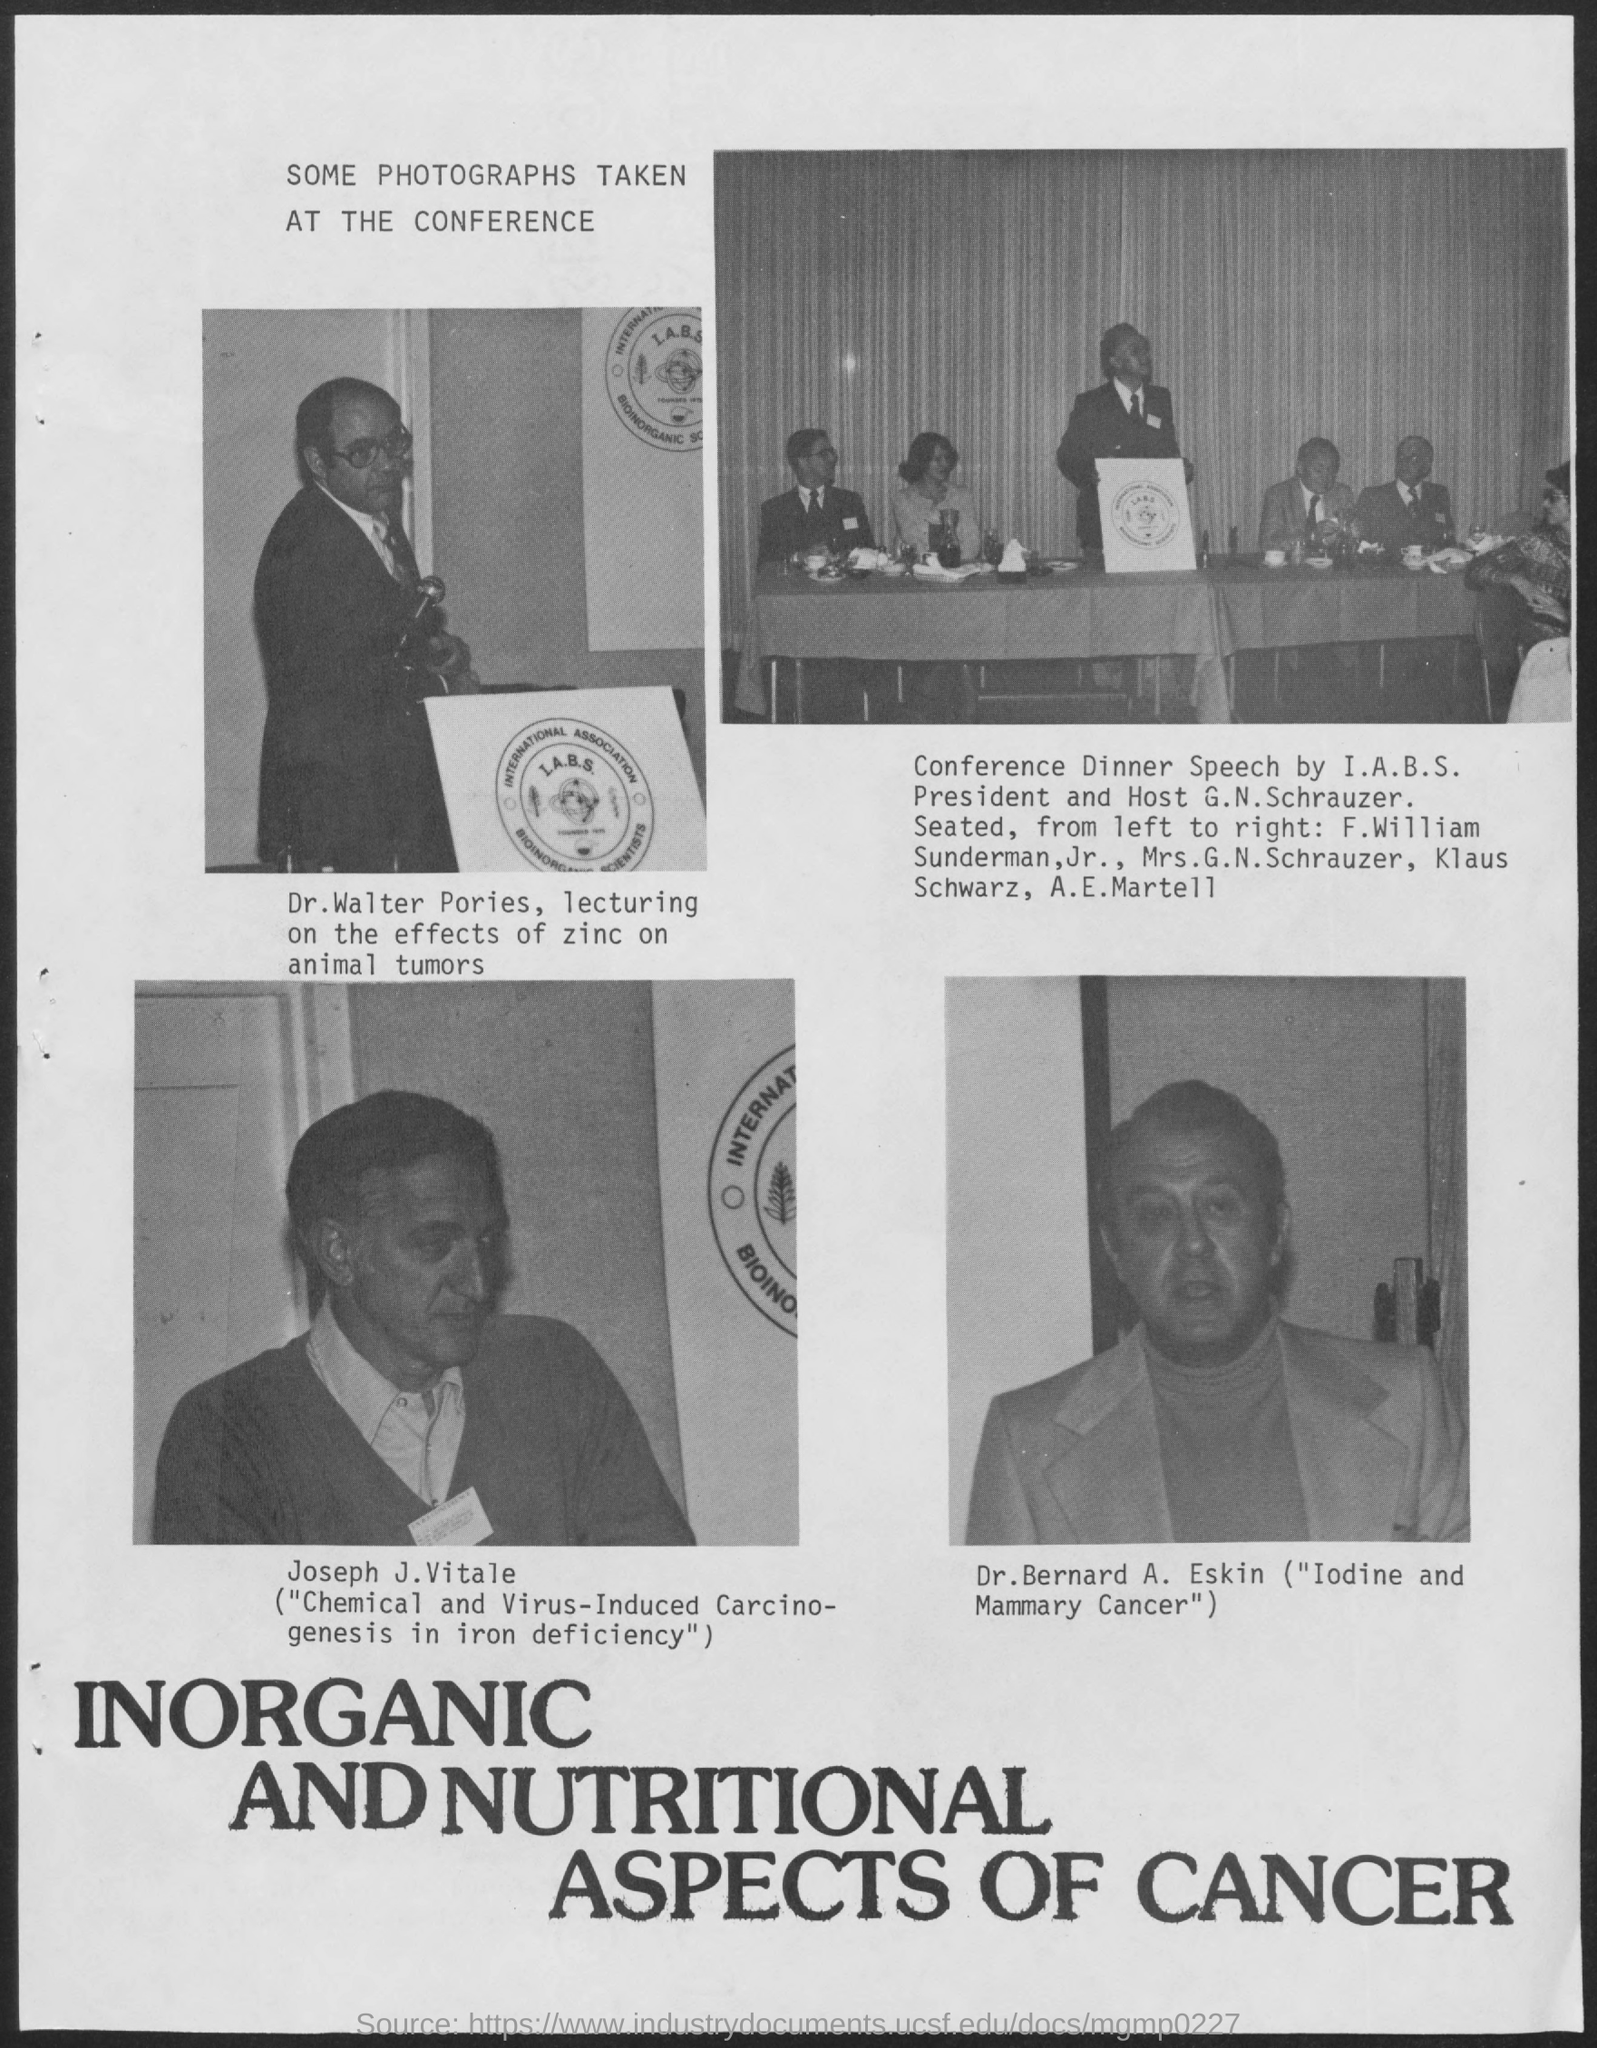Who's image is shown in the lower right corner of the document?
Make the answer very short. Dr. Bernard A. Eskin. 